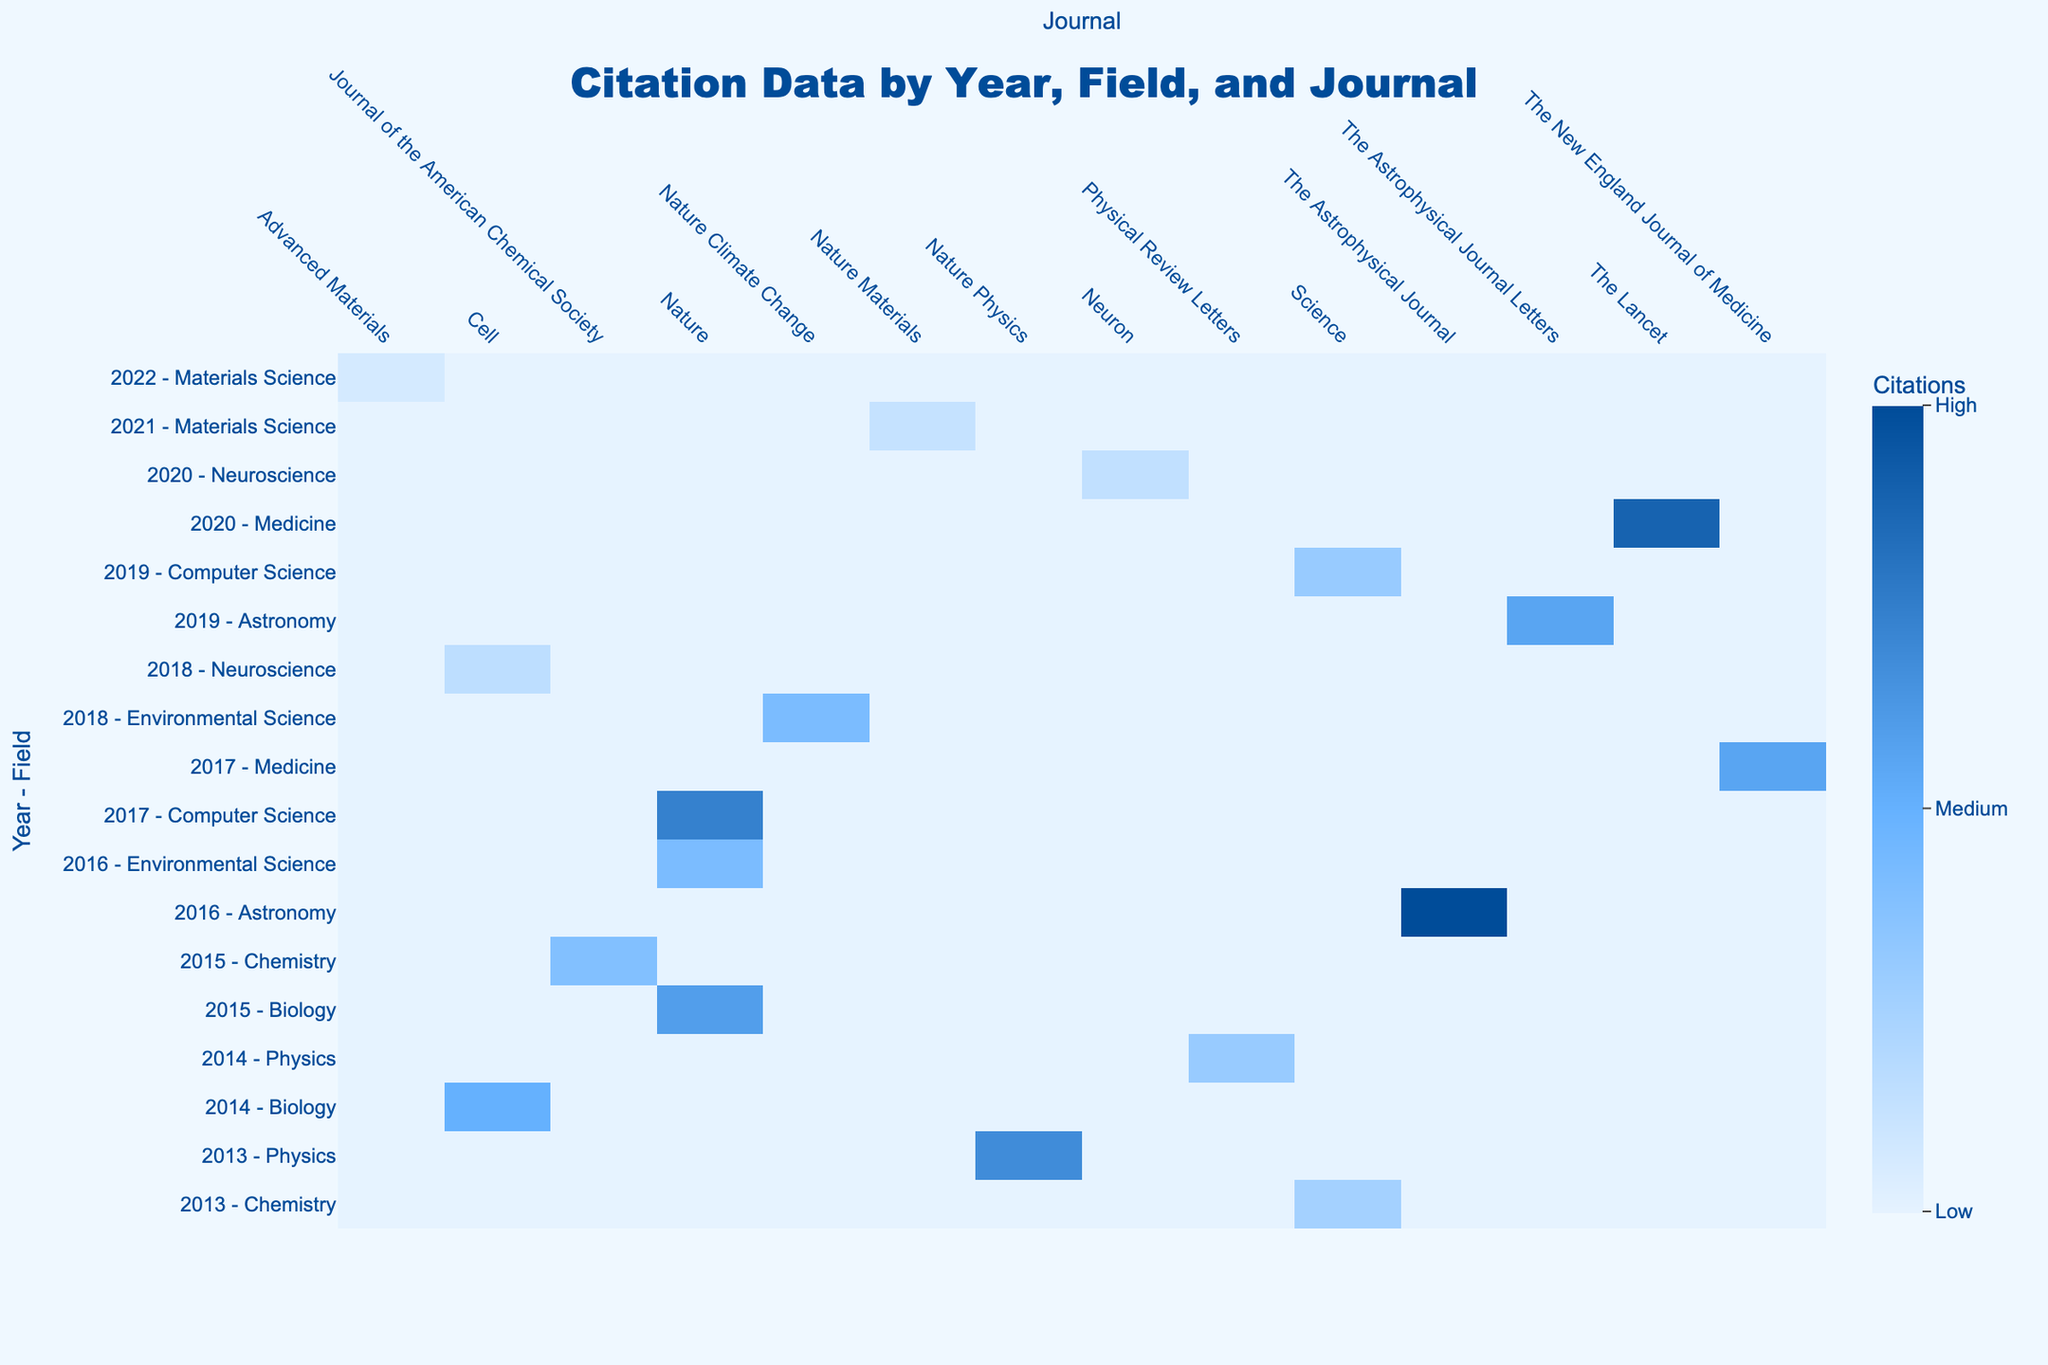What is the highest number of citations in the table? By examining the values in the table, the maximum citation number is 7654, which corresponds to the paper titled "Observation of Gravitational Waves from a Binary Black Hole Merger" published in 2016.
Answer: 7654 Which journal published the most cited paper in 2016? In 2016, the paper with the highest citations is from "The Astrophysical Journal" with 7654 citations for the paper on gravitational waves.
Answer: The Astrophysical Journal How many citations does the paper "CAR T-Cell Therapy in Acute Lymphoblastic Leukemia" have? Looking specifically at the row for the paper titled "CAR T-Cell Therapy in Acute Lymphoblastic Leukemia" from 2017 in the table, it shows there are 4321 citations.
Answer: 4321 What is the average number of citations for papers in Chemistry from the given dataset? Summing the citations for the Chemistry papers gives: 2987 (2015) + 1987 (2013) = 4974. There are two papers, so the average citations are 4974/2 = 2487.
Answer: 2487 Did any Biology paper published after 2015 receive more than 4000 citations? The Biology paper from 2015 received 4567 citations, and no Biology paper after 2015 appears in the data. Thus, the statement is false.
Answer: No What is the total number of citations for Astronomy-related papers? The citations for Astronomy papers are 7654 (2016) and 4321 (2019). Adding these together gives 7654 + 4321 = 11975.
Answer: 11975 Which field has the least number of citations for their most cited paper? The field of Materials Science has the least citations for its most cited paper, which is 987 for the paper published in 2021. Comparing this with other fields, it's the lowest.
Answer: Materials Science How many papers in the table have more than 5000 citations? From the table, the papers with citations over 5000 are: 7654 (2016), 6789 (2020), and 4567 (2015). Counting gives a total of 3 papers.
Answer: 3 Which year had the highest total citations across all fields? By summarizing the citations by year: 2013: 7240, 2014: 6221, 2015: 7554, 2016: 7654, 2017: 4321, 2018: 4444, 2019: 6666, 2020: 6789, 2021: 987, and the highest total is for 2016 with 7654 citations.
Answer: 2016 